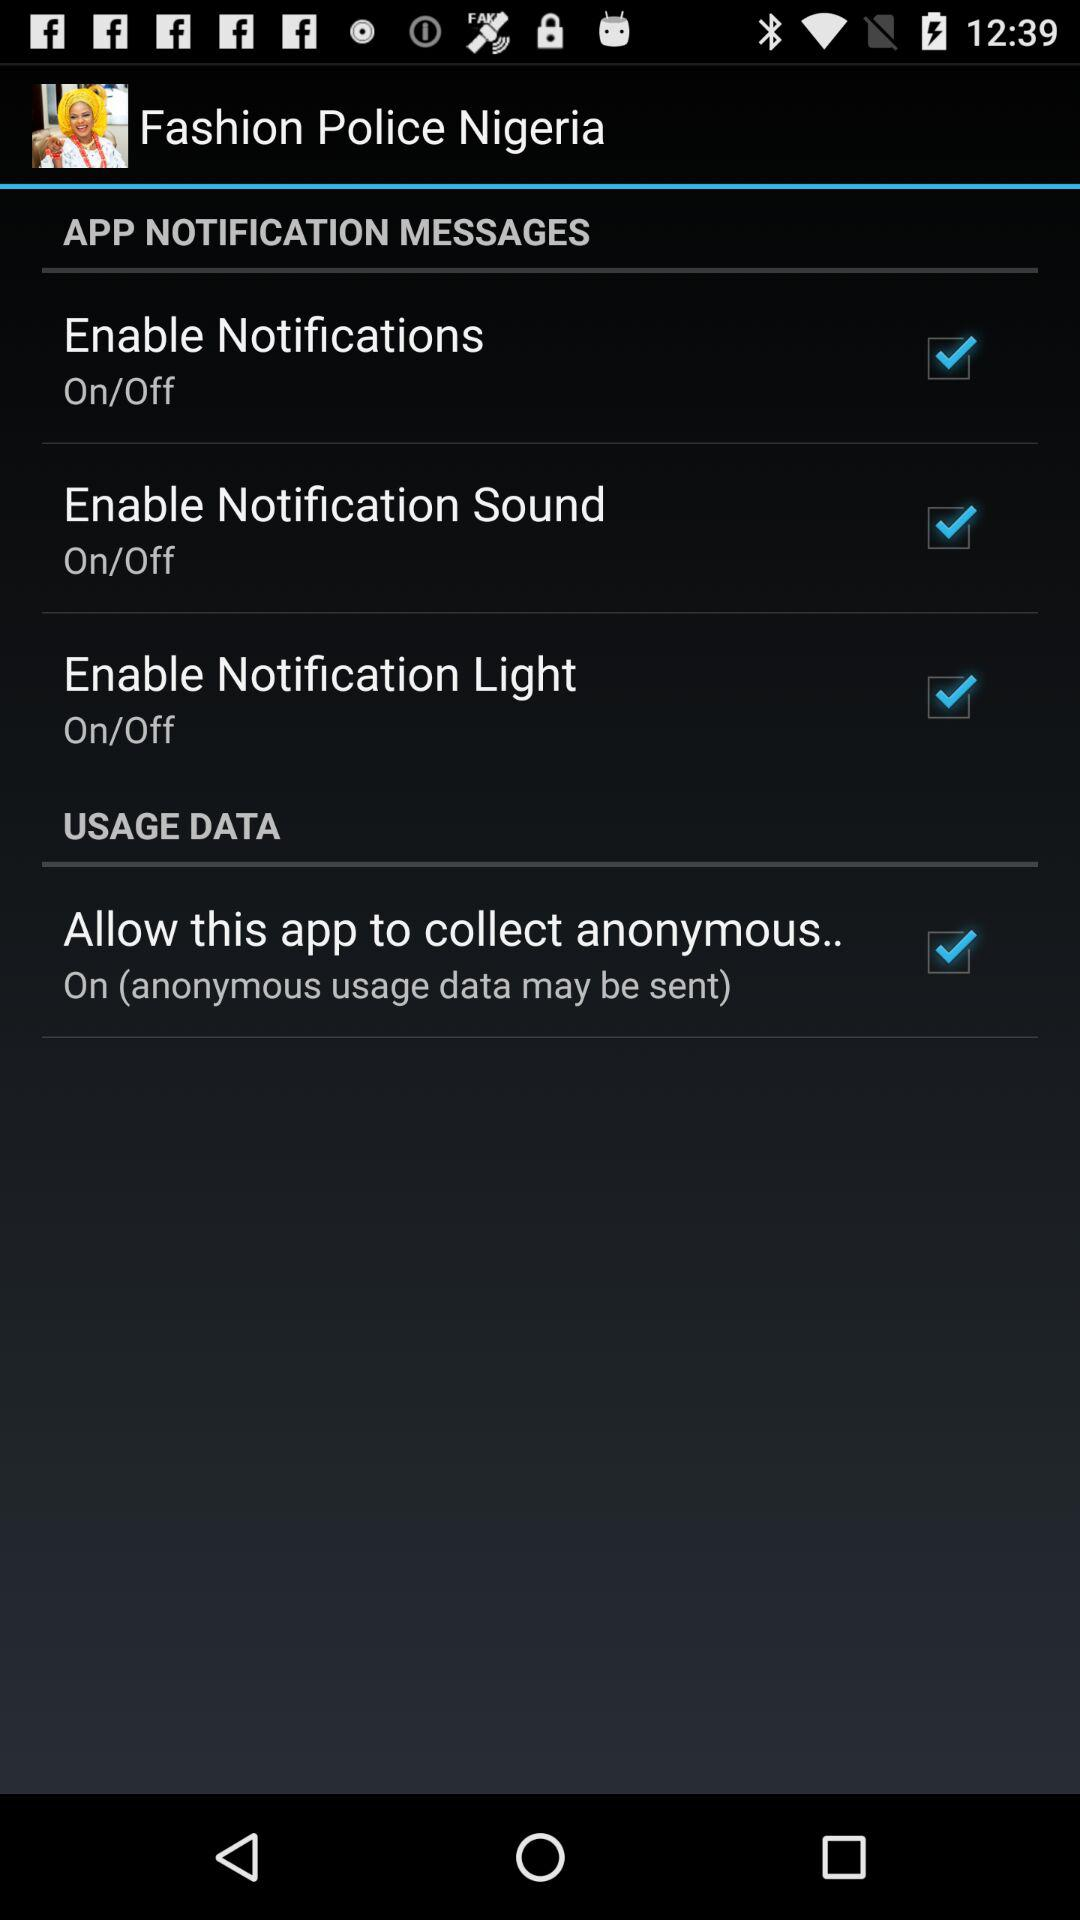What is the status of "Enable Notification Light"? The status of "Enable Notification Light" is "on". 